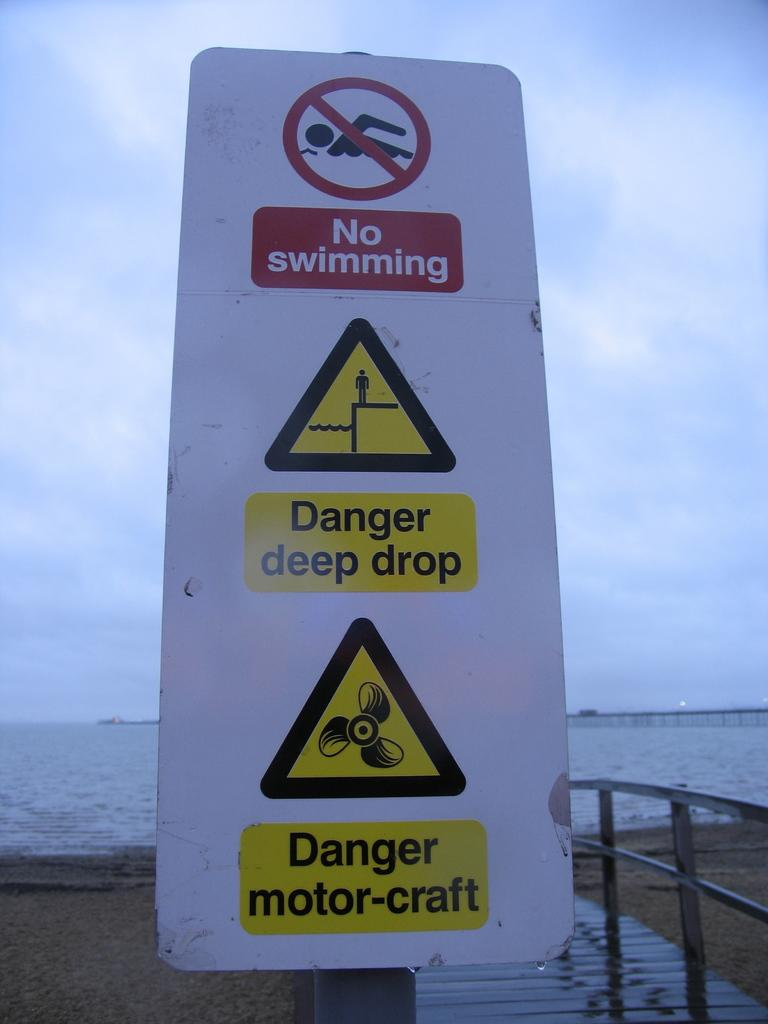Provide a one-sentence caption for the provided image. A sign on the beach warns visitors not to swim and of dangers in the water. 